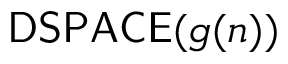Convert formula to latex. <formula><loc_0><loc_0><loc_500><loc_500>{ D S P A C E } ( g ( n ) )</formula> 